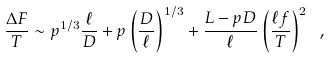Convert formula to latex. <formula><loc_0><loc_0><loc_500><loc_500>\frac { \Delta F } { T } \sim p ^ { 1 / 3 } \frac { \ell } { D } + p \left ( \frac { D } { \ell } \right ) ^ { 1 / 3 } + \frac { L - p D } { \ell } \left ( \frac { \ell f } { T } \right ) ^ { 2 } \ ,</formula> 